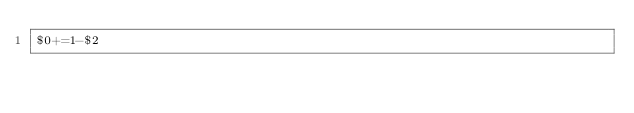<code> <loc_0><loc_0><loc_500><loc_500><_Awk_>$0+=1-$2</code> 